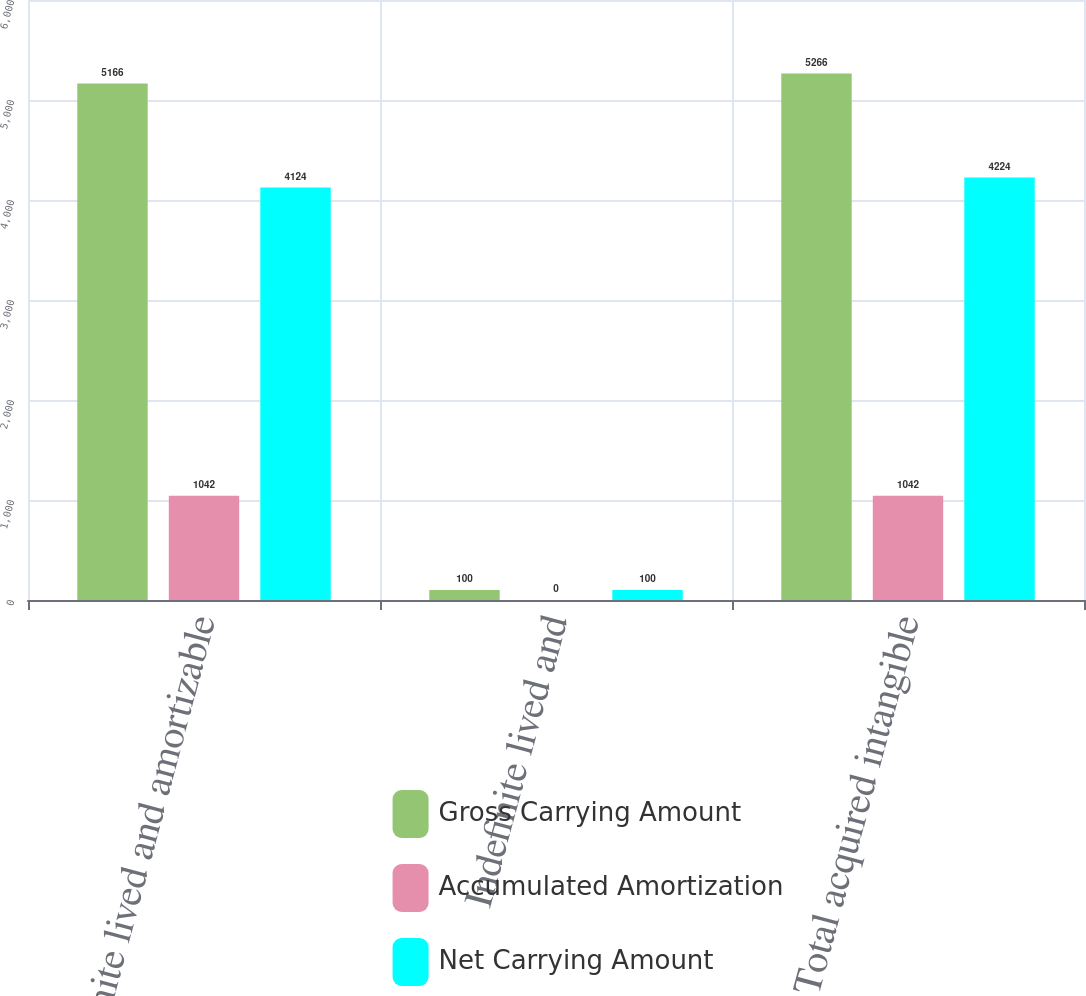<chart> <loc_0><loc_0><loc_500><loc_500><stacked_bar_chart><ecel><fcel>Definite lived and amortizable<fcel>Indefinite lived and<fcel>Total acquired intangible<nl><fcel>Gross Carrying Amount<fcel>5166<fcel>100<fcel>5266<nl><fcel>Accumulated Amortization<fcel>1042<fcel>0<fcel>1042<nl><fcel>Net Carrying Amount<fcel>4124<fcel>100<fcel>4224<nl></chart> 